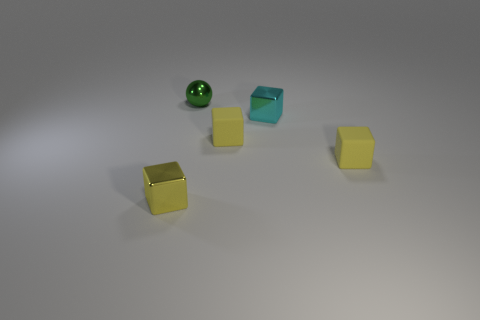Subtract all tiny yellow shiny cubes. How many cubes are left? 3 Subtract all red cylinders. How many yellow blocks are left? 3 Subtract 2 blocks. How many blocks are left? 2 Add 3 yellow matte blocks. How many objects exist? 8 Subtract all cyan cubes. How many cubes are left? 3 Subtract all gray blocks. Subtract all green cylinders. How many blocks are left? 4 Subtract 0 red blocks. How many objects are left? 5 Subtract all cubes. How many objects are left? 1 Subtract all yellow rubber objects. Subtract all tiny yellow metal things. How many objects are left? 2 Add 3 cyan metal blocks. How many cyan metal blocks are left? 4 